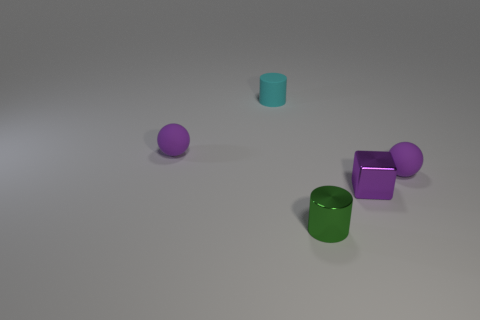There is a green thing that is the same size as the purple block; what is its material?
Ensure brevity in your answer.  Metal. How many objects are tiny rubber balls that are right of the small green metal cylinder or cyan rubber things that are behind the purple metal cube?
Provide a succinct answer. 2. What number of rubber things are balls or purple things?
Make the answer very short. 2. There is a block that is to the right of the green shiny cylinder; what is its material?
Provide a short and direct response. Metal. What is the material of the tiny green thing that is the same shape as the cyan rubber thing?
Your response must be concise. Metal. Is there a small cyan object that is behind the matte object left of the small cyan cylinder?
Provide a short and direct response. Yes. Is the small cyan matte thing the same shape as the small green metal thing?
Make the answer very short. Yes. The other tiny thing that is the same material as the small green object is what shape?
Your answer should be compact. Cube. Are there more purple balls that are behind the tiny metallic cube than small shiny cylinders that are behind the cyan matte cylinder?
Ensure brevity in your answer.  Yes. What number of other objects are there of the same color as the cube?
Give a very brief answer. 2. 